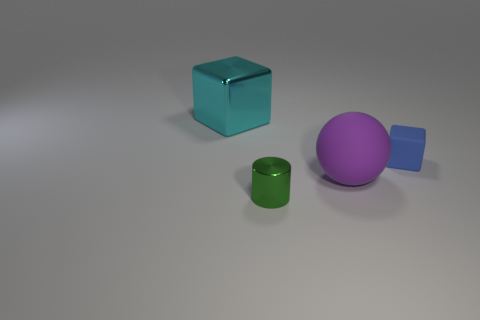Add 1 small metallic cylinders. How many objects exist? 5 Subtract all balls. How many objects are left? 3 Add 1 tiny rubber cubes. How many tiny rubber cubes are left? 2 Add 3 tiny green cylinders. How many tiny green cylinders exist? 4 Subtract 0 blue spheres. How many objects are left? 4 Subtract all tiny blue metal cylinders. Subtract all rubber objects. How many objects are left? 2 